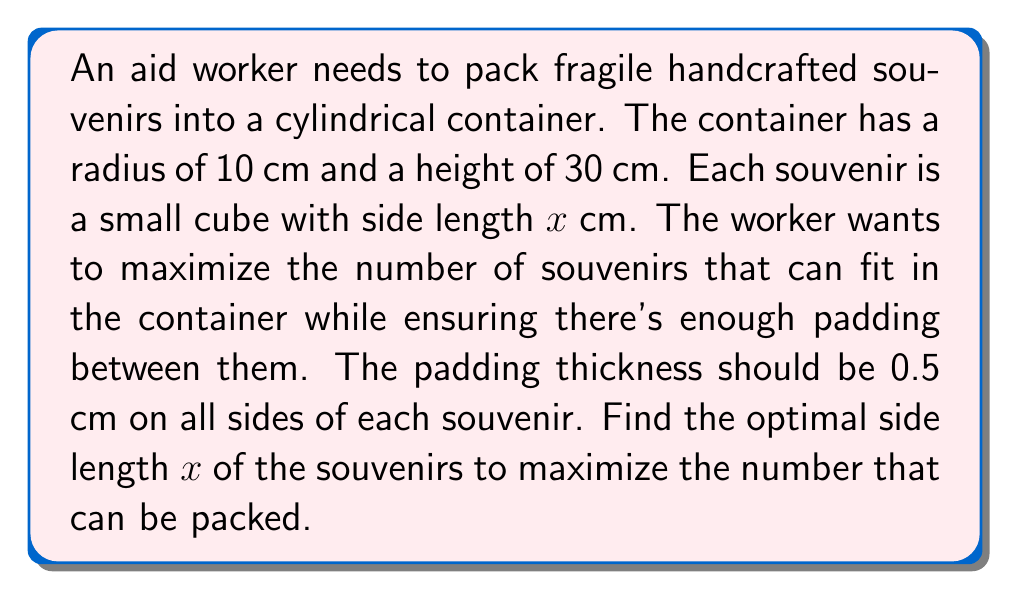Could you help me with this problem? Let's approach this step-by-step:

1) First, we need to determine the number of souvenirs that can fit in each dimension:

   Radial direction: $\frac{2R}{x+1} = \frac{20}{x+1}$ (diameter divided by souvenir width plus padding)
   Height: $\frac{H}{x+1} = \frac{30}{x+1}$ (container height divided by souvenir height plus padding)

2) The total number of souvenirs $N$ is approximately:

   $N = \pi \cdot (\frac{20}{x+1})^2 \cdot \frac{30}{x+1}$

3) Simplifying:

   $N = \frac{12000\pi}{(x+1)^3}$

4) To maximize $N$, we need to minimize $(x+1)^3$. However, $x$ must be positive and realistically, the souvenirs should be at least 1 cm in size.

5) Let's define a polynomial function:

   $f(x) = (x+1)^3$ for $x \geq 1$

6) The minimum of this function in the given range occurs at $x = 1$.

7) Therefore, the optimal size for the souvenirs is 1 cm.

8) With this size, we can fit approximately:

   $N = \frac{12000\pi}{2^3} = 1500\pi \approx 4712$ souvenirs
Answer: 1 cm 